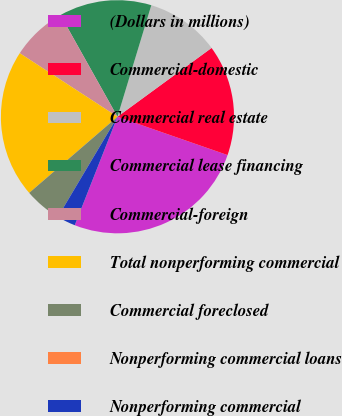<chart> <loc_0><loc_0><loc_500><loc_500><pie_chart><fcel>(Dollars in millions)<fcel>Commercial-domestic<fcel>Commercial real estate<fcel>Commercial lease financing<fcel>Commercial-foreign<fcel>Total nonperforming commercial<fcel>Commercial foreclosed<fcel>Nonperforming commercial loans<fcel>Nonperforming commercial<nl><fcel>25.64%<fcel>15.38%<fcel>10.26%<fcel>12.82%<fcel>7.69%<fcel>20.51%<fcel>5.13%<fcel>0.0%<fcel>2.57%<nl></chart> 